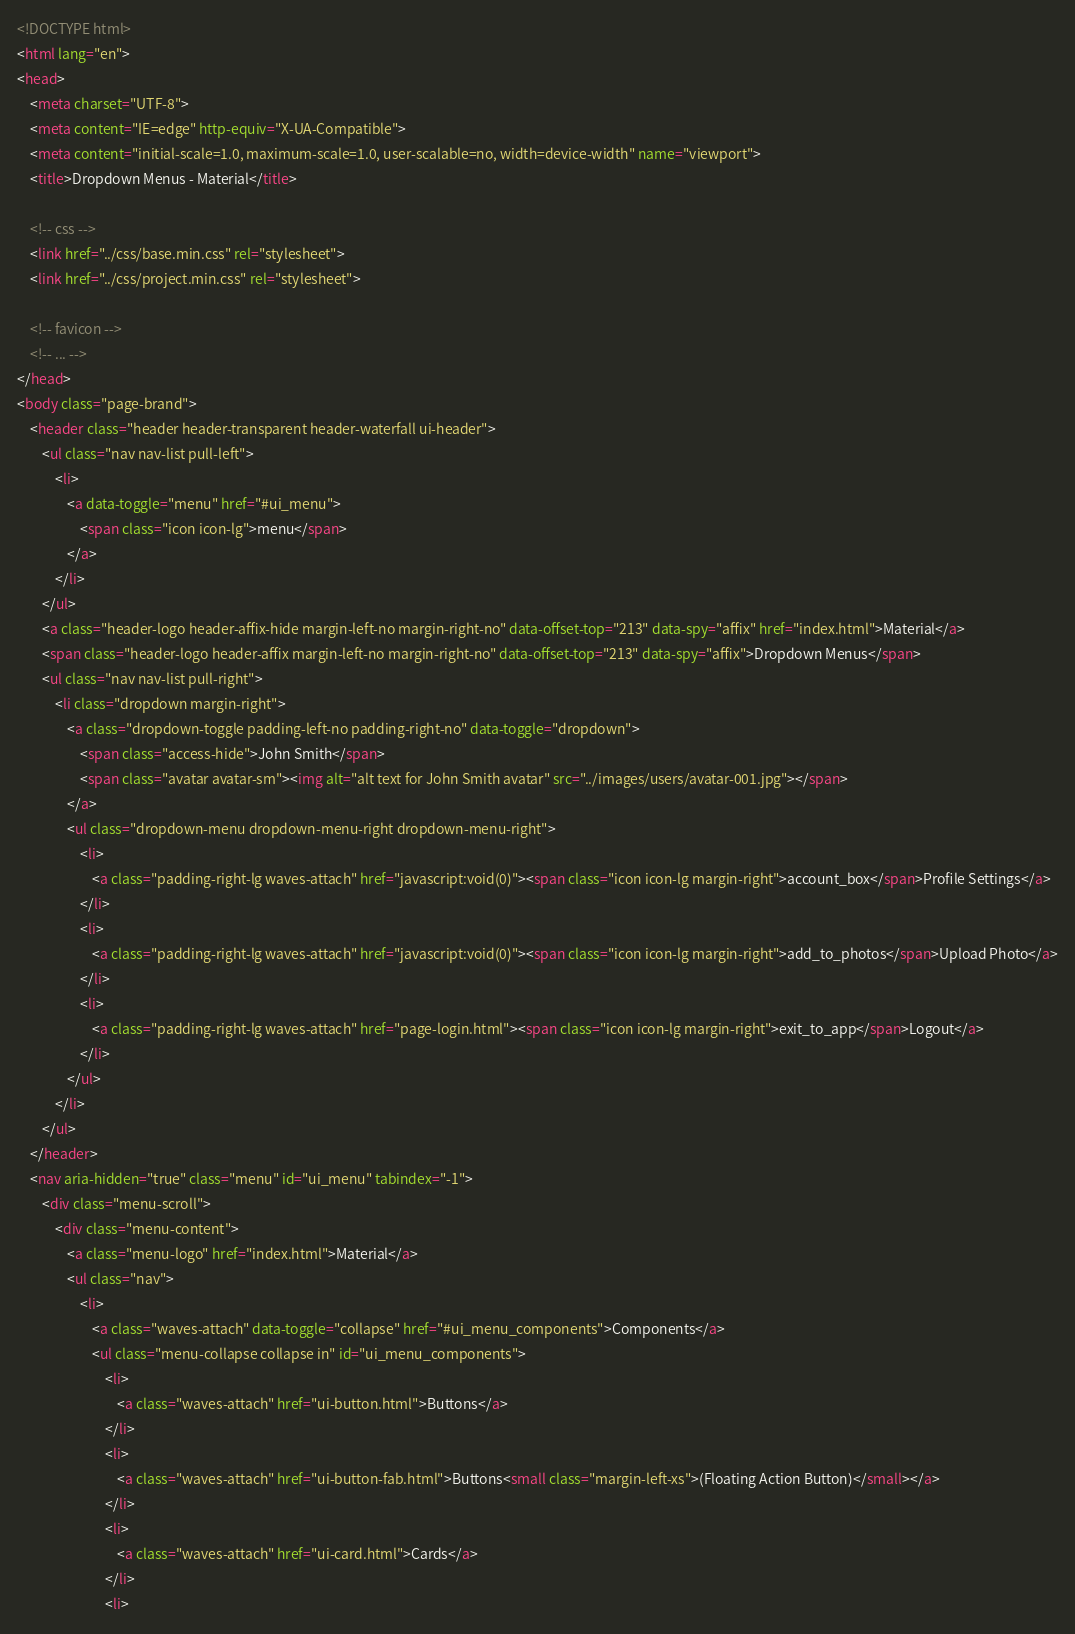Convert code to text. <code><loc_0><loc_0><loc_500><loc_500><_HTML_><!DOCTYPE html>
<html lang="en">
<head>
	<meta charset="UTF-8">
	<meta content="IE=edge" http-equiv="X-UA-Compatible">
	<meta content="initial-scale=1.0, maximum-scale=1.0, user-scalable=no, width=device-width" name="viewport">
	<title>Dropdown Menus - Material</title>

	<!-- css -->
	<link href="../css/base.min.css" rel="stylesheet">
	<link href="../css/project.min.css" rel="stylesheet">

	<!-- favicon -->
	<!-- ... -->
</head>
<body class="page-brand">
	<header class="header header-transparent header-waterfall ui-header">
		<ul class="nav nav-list pull-left">
			<li>
				<a data-toggle="menu" href="#ui_menu">
					<span class="icon icon-lg">menu</span>
				</a>
			</li>
		</ul>
		<a class="header-logo header-affix-hide margin-left-no margin-right-no" data-offset-top="213" data-spy="affix" href="index.html">Material</a>
		<span class="header-logo header-affix margin-left-no margin-right-no" data-offset-top="213" data-spy="affix">Dropdown Menus</span>
		<ul class="nav nav-list pull-right">
			<li class="dropdown margin-right">
				<a class="dropdown-toggle padding-left-no padding-right-no" data-toggle="dropdown">
					<span class="access-hide">John Smith</span>
					<span class="avatar avatar-sm"><img alt="alt text for John Smith avatar" src="../images/users/avatar-001.jpg"></span>
				</a>
				<ul class="dropdown-menu dropdown-menu-right dropdown-menu-right">
					<li>
						<a class="padding-right-lg waves-attach" href="javascript:void(0)"><span class="icon icon-lg margin-right">account_box</span>Profile Settings</a>
					</li>
					<li>
						<a class="padding-right-lg waves-attach" href="javascript:void(0)"><span class="icon icon-lg margin-right">add_to_photos</span>Upload Photo</a>
					</li>
					<li>
						<a class="padding-right-lg waves-attach" href="page-login.html"><span class="icon icon-lg margin-right">exit_to_app</span>Logout</a>
					</li>
				</ul>
			</li>
		</ul>
	</header>
	<nav aria-hidden="true" class="menu" id="ui_menu" tabindex="-1">
		<div class="menu-scroll">
			<div class="menu-content">
				<a class="menu-logo" href="index.html">Material</a>
				<ul class="nav">
					<li>
						<a class="waves-attach" data-toggle="collapse" href="#ui_menu_components">Components</a>
						<ul class="menu-collapse collapse in" id="ui_menu_components">
							<li>
								<a class="waves-attach" href="ui-button.html">Buttons</a>
							</li>
							<li>
								<a class="waves-attach" href="ui-button-fab.html">Buttons<small class="margin-left-xs">(Floating Action Button)</small></a>
							</li>
							<li>
								<a class="waves-attach" href="ui-card.html">Cards</a>
							</li>
							<li></code> 